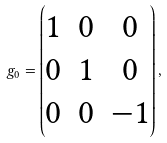<formula> <loc_0><loc_0><loc_500><loc_500>g _ { 0 } = \begin{pmatrix} 1 & 0 & 0 \\ 0 & 1 & 0 \\ 0 & 0 & - 1 \end{pmatrix} ,</formula> 